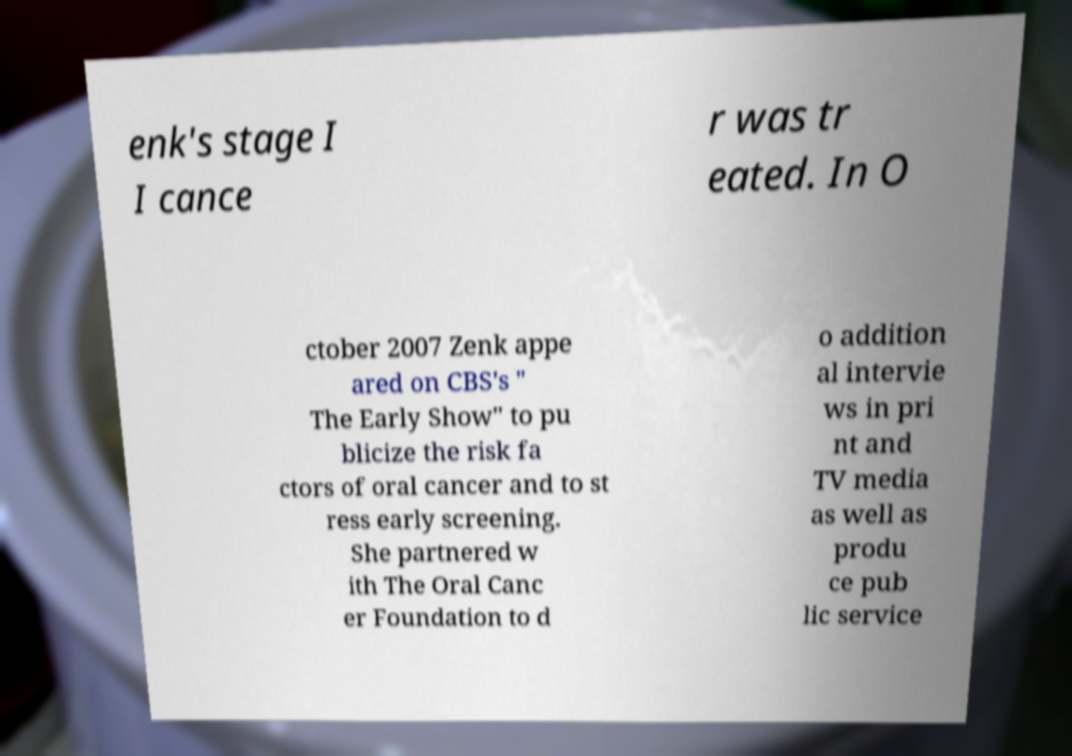Could you extract and type out the text from this image? enk's stage I I cance r was tr eated. In O ctober 2007 Zenk appe ared on CBS's " The Early Show" to pu blicize the risk fa ctors of oral cancer and to st ress early screening. She partnered w ith The Oral Canc er Foundation to d o addition al intervie ws in pri nt and TV media as well as produ ce pub lic service 